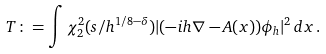<formula> <loc_0><loc_0><loc_500><loc_500>T \colon = \int \chi _ { 2 } ^ { 2 } ( s / h ^ { 1 / 8 - \delta } ) | ( - i h \nabla - A ( x ) ) \phi _ { h } | ^ { 2 } \, d x \, .</formula> 